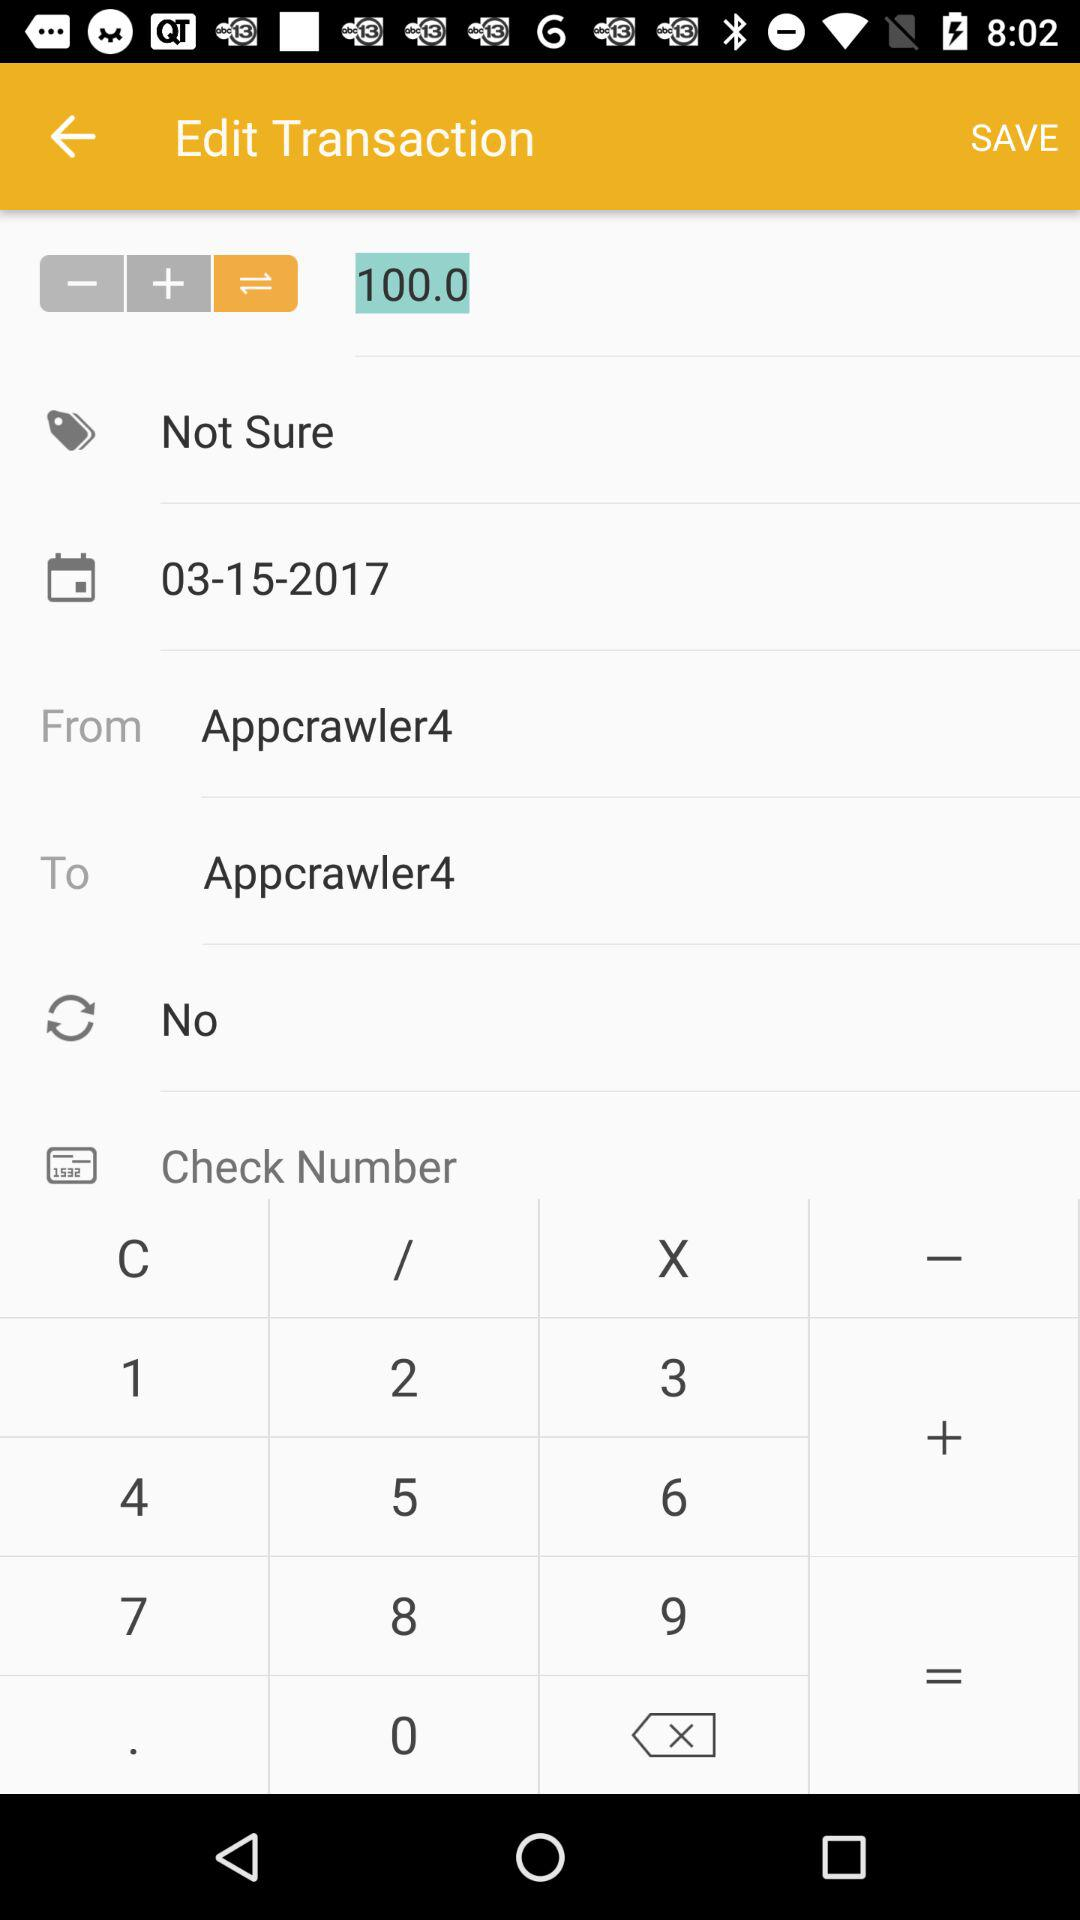What is the username in "From"? The username is "Appcrawler4". 